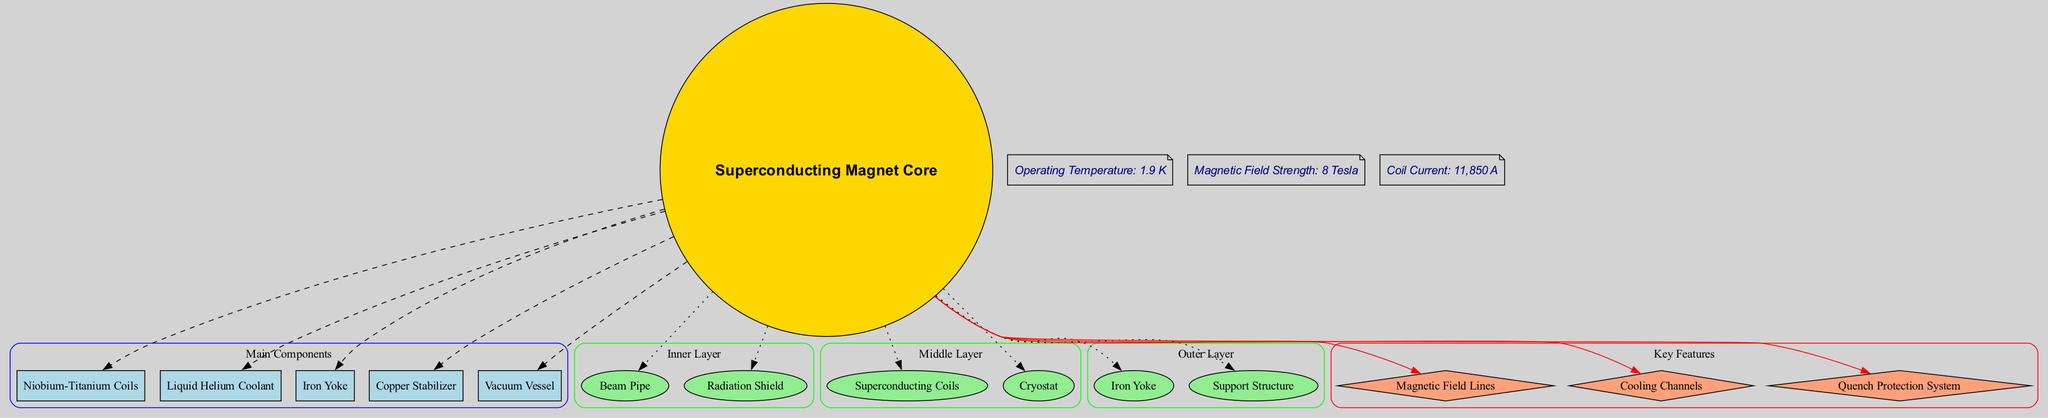What is the central element of the superconducting magnet system? The diagram identifies the central element as the "Superconducting Magnet Core," which is the focal point around which the other components are organized.
Answer: Superconducting Magnet Core How many main components are highlighted in the diagram? The diagram lists five main components which can be counted in the "Main Components" labeled cluster, indicating the total number of distinct parts.
Answer: 5 What material are the superconducting coils made from? The diagram specifies "Niobium-Titanium Coils" as one of the key components, denoting that this material composition is fundamental to the superconducting coils.
Answer: Niobium-Titanium What is the operating temperature for the magnet system? In the annotations segment of the diagram, the operating temperature is explicitly stated as "1.9 K," which indicates the required environmental condition for optimal operation.
Answer: 1.9 K Which layer contains the cryostat? The diagram indicates that the "Middle Layer" consists of the "Cryostat" among other components, demonstrating its placement within the structure.
Answer: Middle Layer Explain the relationship between the magnetic field strength and the cooling channels. The diagram illustrates that both are key features of the superconducting magnet system; while magnetic field strength (8 Tesla) is listed in the annotations, cooling channels are also depicted among key features, implying they function collectively to ensure performance stability.
Answer: Magnetic Field Strength and Cooling Channels are both essential for operation What does the "quench protection system" indicate in the context of superconducting materials? The diagram highlights "Quench Protection System" as a key feature, which implies a safety mechanism to prevent loss of superconductivity, indicating that this feature is critical for maintaining the operational integrity of superconducting materials under varying conditions.
Answer: Safety mechanism for superconductivity What color scheme is used for the main components in the diagram? The subgraph for the main components is filled with "lightblue," which is specified in the attributes of the diagram and suggests a cohesive visual theme applied across this category.
Answer: Lightblue What is the coil current as mentioned in the annotations? The annotations section of the diagram mentions "Coil Current: 11,850 A," providing a precise measurement of the current necessary for the superconducting coils to operate effectively.
Answer: 11,850 A 